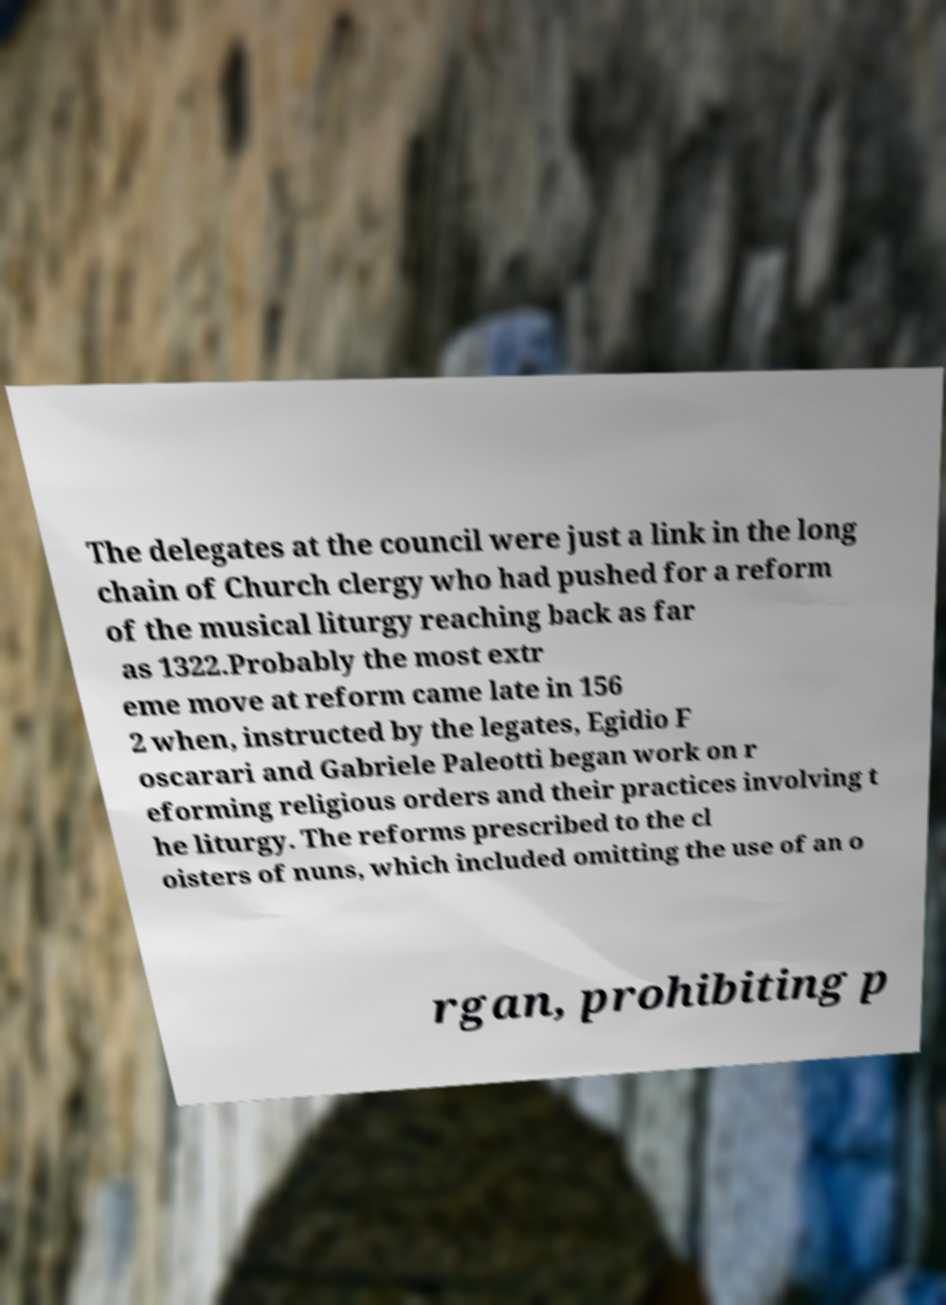There's text embedded in this image that I need extracted. Can you transcribe it verbatim? The delegates at the council were just a link in the long chain of Church clergy who had pushed for a reform of the musical liturgy reaching back as far as 1322.Probably the most extr eme move at reform came late in 156 2 when, instructed by the legates, Egidio F oscarari and Gabriele Paleotti began work on r eforming religious orders and their practices involving t he liturgy. The reforms prescribed to the cl oisters of nuns, which included omitting the use of an o rgan, prohibiting p 